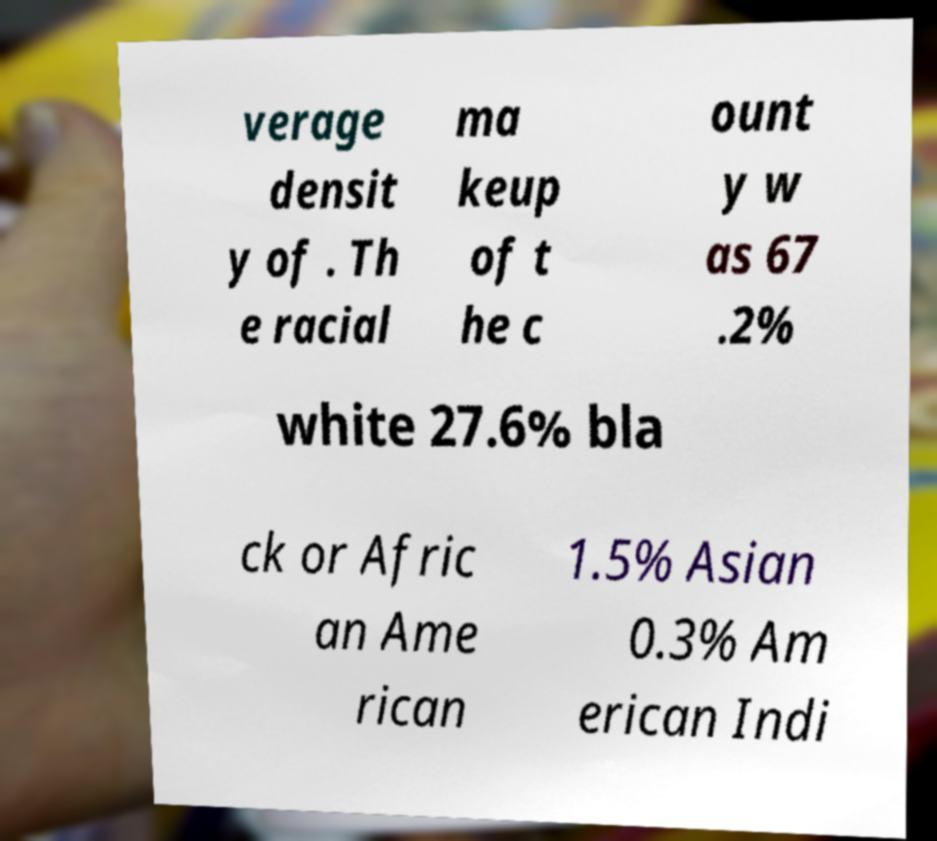Can you accurately transcribe the text from the provided image for me? verage densit y of . Th e racial ma keup of t he c ount y w as 67 .2% white 27.6% bla ck or Afric an Ame rican 1.5% Asian 0.3% Am erican Indi 